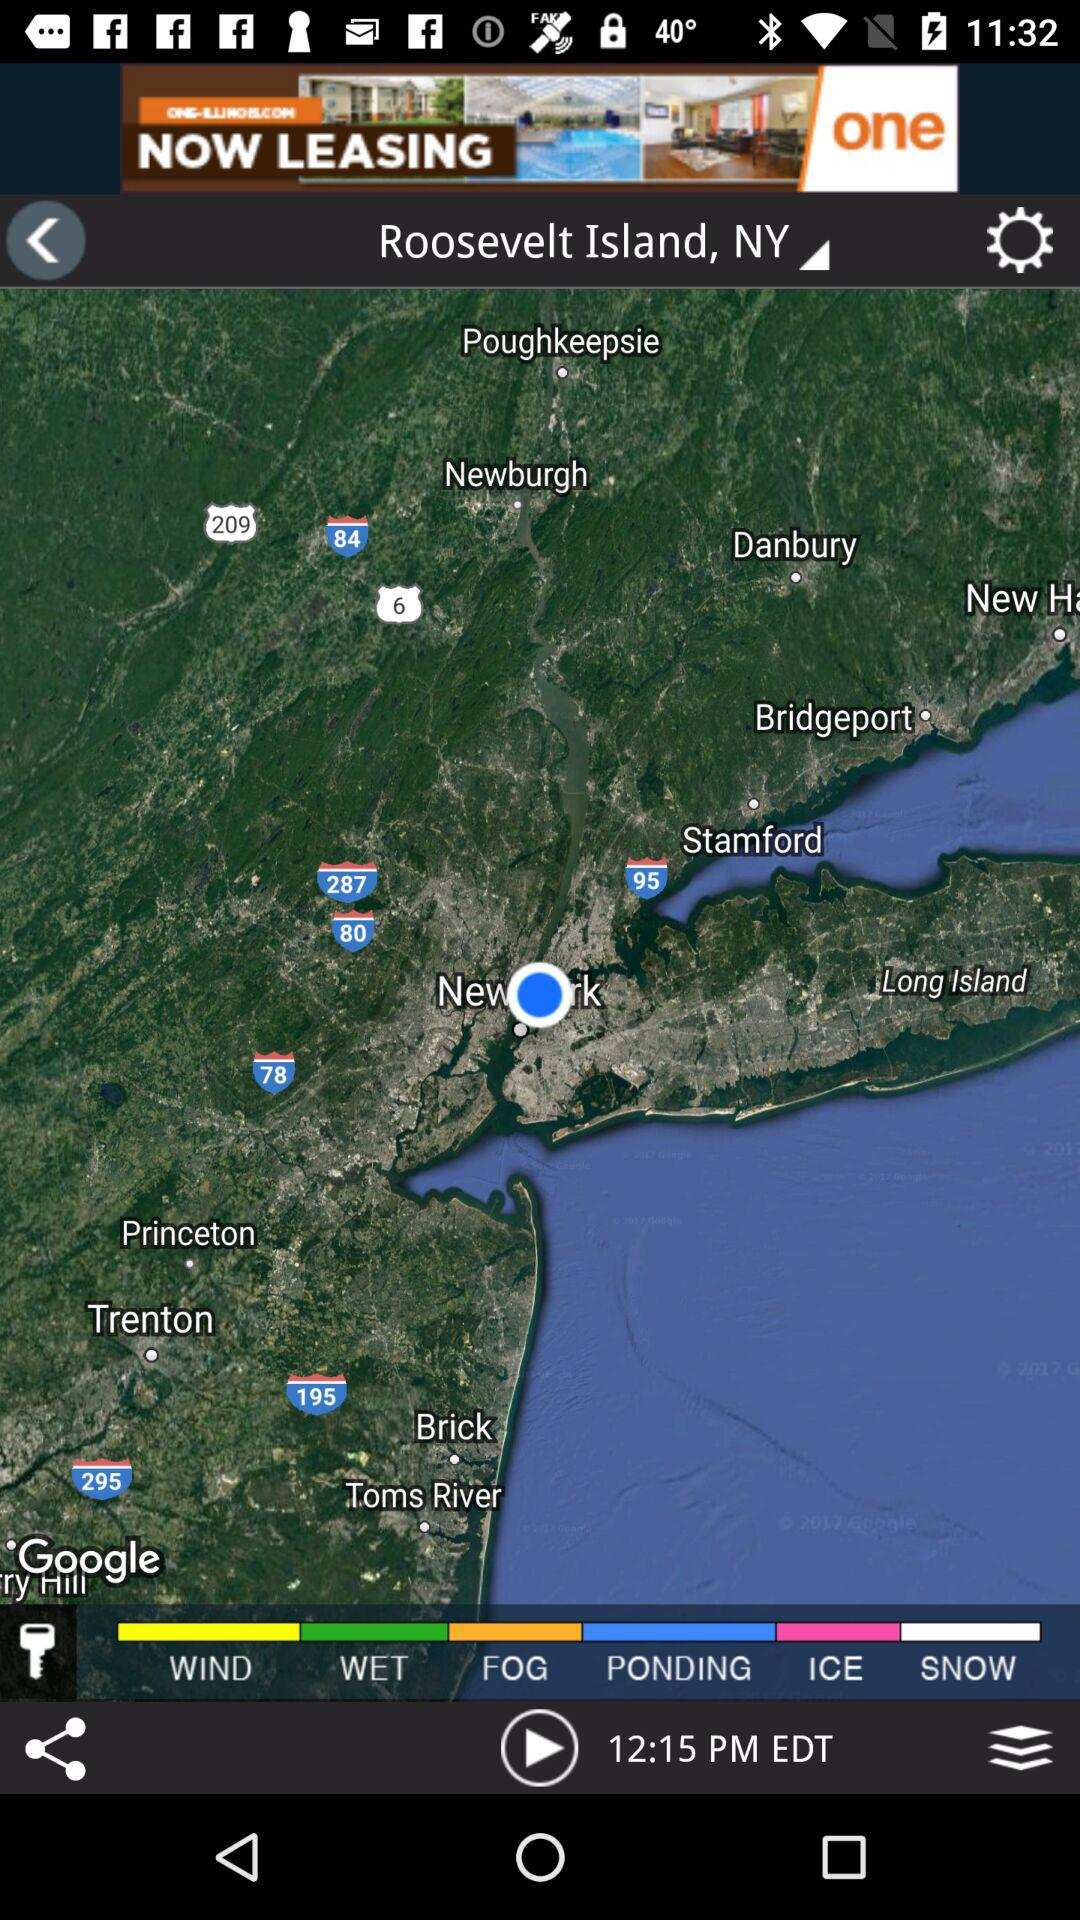How many weather conditions are displayed on the screen?
Answer the question using a single word or phrase. 6 